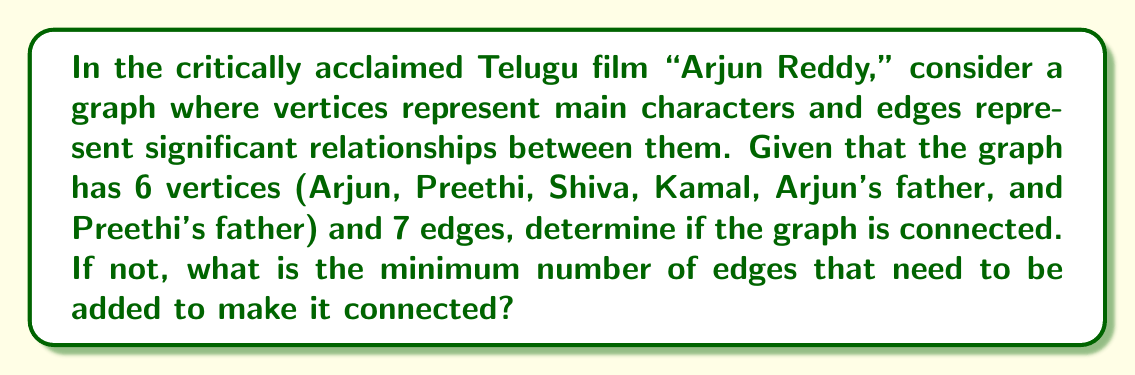Provide a solution to this math problem. To solve this problem, we need to understand the concept of graph connectedness and apply it to the given scenario.

1. Graph Connectedness:
   A graph is connected if there exists a path between every pair of vertices. In other words, it's possible to reach any vertex from any other vertex by following the edges.

2. Minimum Number of Edges for Connectedness:
   For a graph with $n$ vertices to be connected, it must have at least $n-1$ edges. This forms a tree-like structure connecting all vertices.

3. Given Information:
   - Number of vertices: $n = 6$
   - Number of edges: $e = 7$

4. Analysis:
   - Minimum edges required for connectedness: $n - 1 = 6 - 1 = 5$
   - Given edges: $e = 7$

   Since $e > n - 1$, the graph has more than the minimum required edges for connectedness.

5. Conclusion:
   With 7 edges and 6 vertices, the graph is guaranteed to be connected. There's no need to add any edges.

6. Visualization:
   [asy]
   unitsize(1cm);
   
   pair A = (0,0), B = (2,0), C = (1,1.73), D = (-1,1.73), E = (-2,0), F = (0,-2);
   
   draw(A--B--C--D--E--A--F--B);
   
   dot("Arjun", A, S);
   dot("Preethi", B, SE);
   dot("Shiva", C, N);
   dot("Kamal", D, N);
   dot("Arjun's father", E, SW);
   dot("Preethi's father", F, S);
   [/asy]

   This is one possible configuration of the graph, demonstrating its connectedness.
Answer: The graph is connected. No additional edges are needed. 